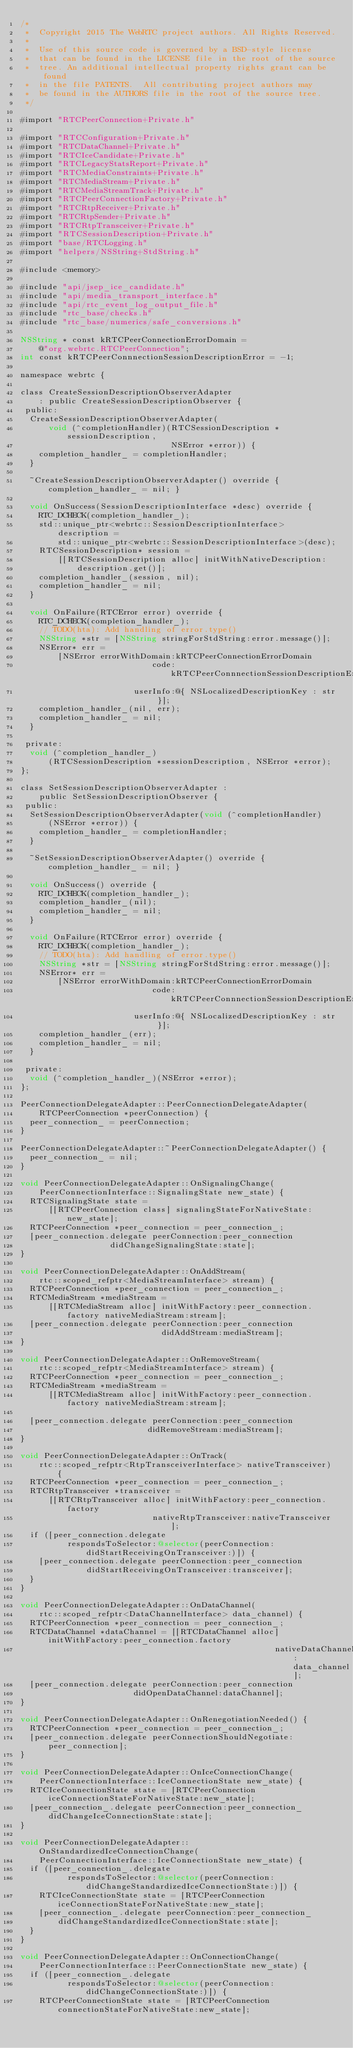Convert code to text. <code><loc_0><loc_0><loc_500><loc_500><_ObjectiveC_>/*
 *  Copyright 2015 The WebRTC project authors. All Rights Reserved.
 *
 *  Use of this source code is governed by a BSD-style license
 *  that can be found in the LICENSE file in the root of the source
 *  tree. An additional intellectual property rights grant can be found
 *  in the file PATENTS.  All contributing project authors may
 *  be found in the AUTHORS file in the root of the source tree.
 */

#import "RTCPeerConnection+Private.h"

#import "RTCConfiguration+Private.h"
#import "RTCDataChannel+Private.h"
#import "RTCIceCandidate+Private.h"
#import "RTCLegacyStatsReport+Private.h"
#import "RTCMediaConstraints+Private.h"
#import "RTCMediaStream+Private.h"
#import "RTCMediaStreamTrack+Private.h"
#import "RTCPeerConnectionFactory+Private.h"
#import "RTCRtpReceiver+Private.h"
#import "RTCRtpSender+Private.h"
#import "RTCRtpTransceiver+Private.h"
#import "RTCSessionDescription+Private.h"
#import "base/RTCLogging.h"
#import "helpers/NSString+StdString.h"

#include <memory>

#include "api/jsep_ice_candidate.h"
#include "api/media_transport_interface.h"
#include "api/rtc_event_log_output_file.h"
#include "rtc_base/checks.h"
#include "rtc_base/numerics/safe_conversions.h"

NSString * const kRTCPeerConnectionErrorDomain =
    @"org.webrtc.RTCPeerConnection";
int const kRTCPeerConnnectionSessionDescriptionError = -1;

namespace webrtc {

class CreateSessionDescriptionObserverAdapter
    : public CreateSessionDescriptionObserver {
 public:
  CreateSessionDescriptionObserverAdapter(
      void (^completionHandler)(RTCSessionDescription *sessionDescription,
                                NSError *error)) {
    completion_handler_ = completionHandler;
  }

  ~CreateSessionDescriptionObserverAdapter() override { completion_handler_ = nil; }

  void OnSuccess(SessionDescriptionInterface *desc) override {
    RTC_DCHECK(completion_handler_);
    std::unique_ptr<webrtc::SessionDescriptionInterface> description =
        std::unique_ptr<webrtc::SessionDescriptionInterface>(desc);
    RTCSessionDescription* session =
        [[RTCSessionDescription alloc] initWithNativeDescription:
            description.get()];
    completion_handler_(session, nil);
    completion_handler_ = nil;
  }

  void OnFailure(RTCError error) override {
    RTC_DCHECK(completion_handler_);
    // TODO(hta): Add handling of error.type()
    NSString *str = [NSString stringForStdString:error.message()];
    NSError* err =
        [NSError errorWithDomain:kRTCPeerConnectionErrorDomain
                            code:kRTCPeerConnnectionSessionDescriptionError
                        userInfo:@{ NSLocalizedDescriptionKey : str }];
    completion_handler_(nil, err);
    completion_handler_ = nil;
  }

 private:
  void (^completion_handler_)
      (RTCSessionDescription *sessionDescription, NSError *error);
};

class SetSessionDescriptionObserverAdapter :
    public SetSessionDescriptionObserver {
 public:
  SetSessionDescriptionObserverAdapter(void (^completionHandler)
      (NSError *error)) {
    completion_handler_ = completionHandler;
  }

  ~SetSessionDescriptionObserverAdapter() override { completion_handler_ = nil; }

  void OnSuccess() override {
    RTC_DCHECK(completion_handler_);
    completion_handler_(nil);
    completion_handler_ = nil;
  }

  void OnFailure(RTCError error) override {
    RTC_DCHECK(completion_handler_);
    // TODO(hta): Add handling of error.type()
    NSString *str = [NSString stringForStdString:error.message()];
    NSError* err =
        [NSError errorWithDomain:kRTCPeerConnectionErrorDomain
                            code:kRTCPeerConnnectionSessionDescriptionError
                        userInfo:@{ NSLocalizedDescriptionKey : str }];
    completion_handler_(err);
    completion_handler_ = nil;
  }

 private:
  void (^completion_handler_)(NSError *error);
};

PeerConnectionDelegateAdapter::PeerConnectionDelegateAdapter(
    RTCPeerConnection *peerConnection) {
  peer_connection_ = peerConnection;
}

PeerConnectionDelegateAdapter::~PeerConnectionDelegateAdapter() {
  peer_connection_ = nil;
}

void PeerConnectionDelegateAdapter::OnSignalingChange(
    PeerConnectionInterface::SignalingState new_state) {
  RTCSignalingState state =
      [[RTCPeerConnection class] signalingStateForNativeState:new_state];
  RTCPeerConnection *peer_connection = peer_connection_;
  [peer_connection.delegate peerConnection:peer_connection
                   didChangeSignalingState:state];
}

void PeerConnectionDelegateAdapter::OnAddStream(
    rtc::scoped_refptr<MediaStreamInterface> stream) {
  RTCPeerConnection *peer_connection = peer_connection_;
  RTCMediaStream *mediaStream =
      [[RTCMediaStream alloc] initWithFactory:peer_connection.factory nativeMediaStream:stream];
  [peer_connection.delegate peerConnection:peer_connection
                              didAddStream:mediaStream];
}

void PeerConnectionDelegateAdapter::OnRemoveStream(
    rtc::scoped_refptr<MediaStreamInterface> stream) {
  RTCPeerConnection *peer_connection = peer_connection_;
  RTCMediaStream *mediaStream =
      [[RTCMediaStream alloc] initWithFactory:peer_connection.factory nativeMediaStream:stream];

  [peer_connection.delegate peerConnection:peer_connection
                           didRemoveStream:mediaStream];
}

void PeerConnectionDelegateAdapter::OnTrack(
    rtc::scoped_refptr<RtpTransceiverInterface> nativeTransceiver) {
  RTCPeerConnection *peer_connection = peer_connection_;
  RTCRtpTransceiver *transceiver =
      [[RTCRtpTransceiver alloc] initWithFactory:peer_connection.factory
                            nativeRtpTransceiver:nativeTransceiver];
  if ([peer_connection.delegate
          respondsToSelector:@selector(peerConnection:didStartReceivingOnTransceiver:)]) {
    [peer_connection.delegate peerConnection:peer_connection
              didStartReceivingOnTransceiver:transceiver];
  }
}

void PeerConnectionDelegateAdapter::OnDataChannel(
    rtc::scoped_refptr<DataChannelInterface> data_channel) {
  RTCPeerConnection *peer_connection = peer_connection_;
  RTCDataChannel *dataChannel = [[RTCDataChannel alloc] initWithFactory:peer_connection.factory
                                                      nativeDataChannel:data_channel];
  [peer_connection.delegate peerConnection:peer_connection
                        didOpenDataChannel:dataChannel];
}

void PeerConnectionDelegateAdapter::OnRenegotiationNeeded() {
  RTCPeerConnection *peer_connection = peer_connection_;
  [peer_connection.delegate peerConnectionShouldNegotiate:peer_connection];
}

void PeerConnectionDelegateAdapter::OnIceConnectionChange(
    PeerConnectionInterface::IceConnectionState new_state) {
  RTCIceConnectionState state = [RTCPeerConnection iceConnectionStateForNativeState:new_state];
  [peer_connection_.delegate peerConnection:peer_connection_ didChangeIceConnectionState:state];
}

void PeerConnectionDelegateAdapter::OnStandardizedIceConnectionChange(
    PeerConnectionInterface::IceConnectionState new_state) {
  if ([peer_connection_.delegate
          respondsToSelector:@selector(peerConnection:didChangeStandardizedIceConnectionState:)]) {
    RTCIceConnectionState state = [RTCPeerConnection iceConnectionStateForNativeState:new_state];
    [peer_connection_.delegate peerConnection:peer_connection_
        didChangeStandardizedIceConnectionState:state];
  }
}

void PeerConnectionDelegateAdapter::OnConnectionChange(
    PeerConnectionInterface::PeerConnectionState new_state) {
  if ([peer_connection_.delegate
          respondsToSelector:@selector(peerConnection:didChangeConnectionState:)]) {
    RTCPeerConnectionState state = [RTCPeerConnection connectionStateForNativeState:new_state];</code> 